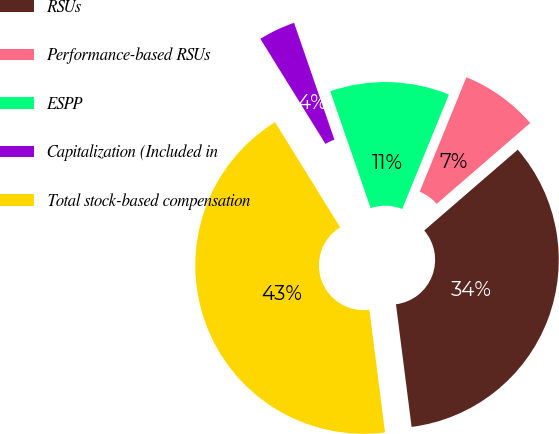Convert chart. <chart><loc_0><loc_0><loc_500><loc_500><pie_chart><fcel>RSUs<fcel>Performance-based RSUs<fcel>ESPP<fcel>Capitalization (Included in<fcel>Total stock-based compensation<nl><fcel>34.32%<fcel>7.49%<fcel>11.46%<fcel>3.53%<fcel>43.19%<nl></chart> 